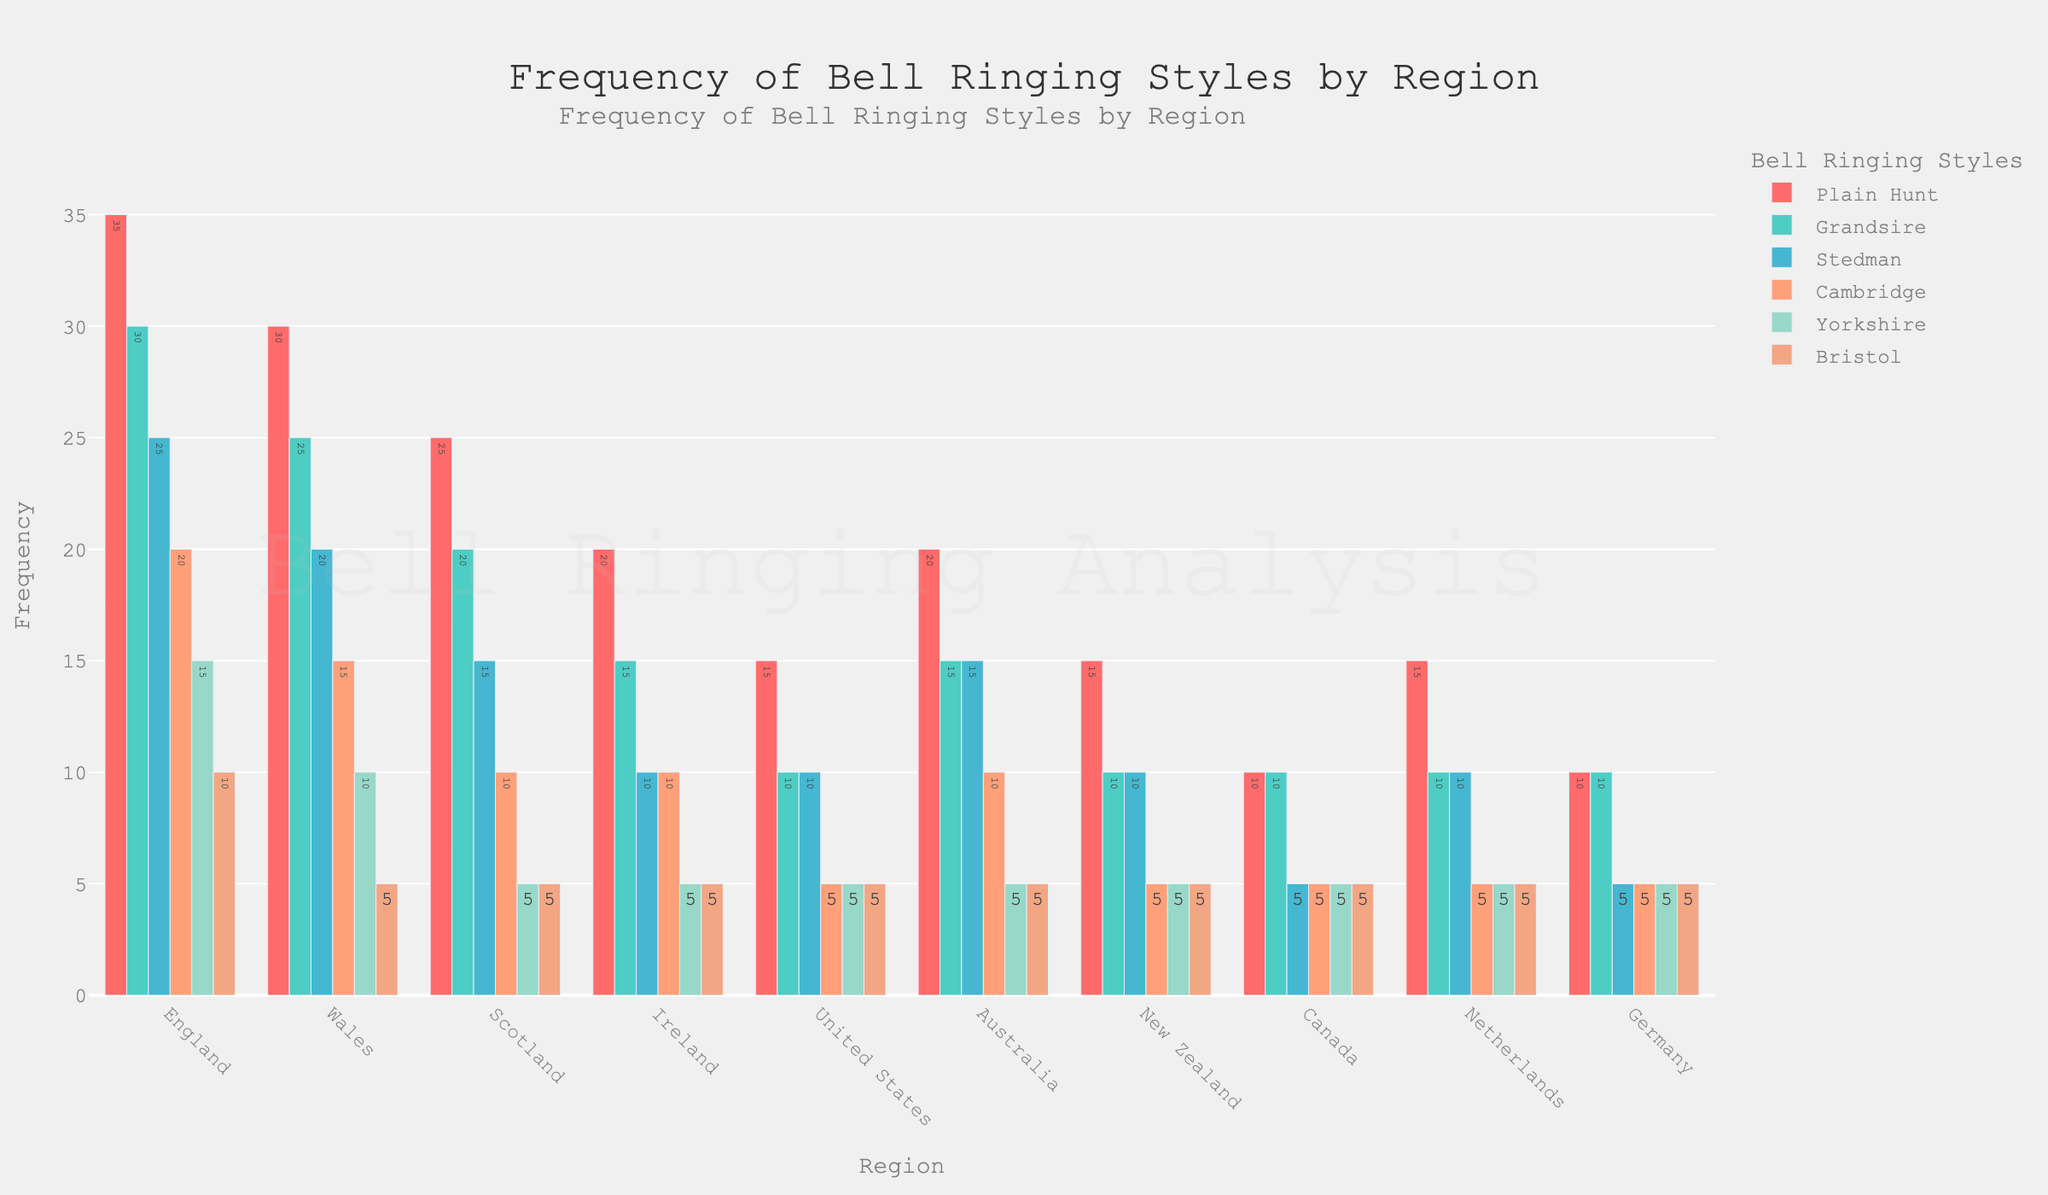What region uses the Grandsire style the most? Look at the Grandsire style (second set of bars from the left), identify the highest bar which is in the "England" region.
Answer: England Compare the use of the Plain Hunt style in the United States and Australia. Which region uses it more? Check the bars representing the Plain Hunt style (first set of bars) for the United States and Australia. Australia's bar is higher than the United States.
Answer: Australia In which region is the Cambridge style used as frequently as the Yorkshire style? Identify and compare the bars for Cambridge and Yorkshire styles across all regions. In "Ireland", both Cambridge and Yorkshire styles have equal heights at 10 units.
Answer: Ireland What is the total frequency of the Stedman style across England and Germany? Add the frequency of Stedman style in England (25) and Germany (5).
Answer: 30 Which region has the least frequency in ringing styles overall? Sum up all the styles for each region and find the smallest total. Canada has the smallest total frequency.
Answer: Canada What’s the most frequently used bell ringing style in England? In the England section, find the highest bar across all styles. Plain Hunt is the highest at 35.
Answer: Plain Hunt Compare the frequency of the Bristol style in Scotland and Wales. What is the difference in frequencies? Subtract the frequency of Bristol in Scotland (5) from that in Wales (5), resulting in zero difference.
Answer: 0 Which bell ringing style in the Netherlands is used exactly the same as in New Zealand? Identify the styles in the Netherlands and New Zealand that have equal height. Plain Hunt (15), Grandsire (10), Stedman (10), Cambridge (5), Yorkshire (5), and Bristol (5) are the same in both regions.
Answer: Plain Hunt, Grandsire, Stedman, Cambridge, Yorkshire, Bristol How many more times is the Plain Hunt style used in England compared to Canada? Subtract the Plain Hunt frequency in Canada (10) from England (35).
Answer: 25 